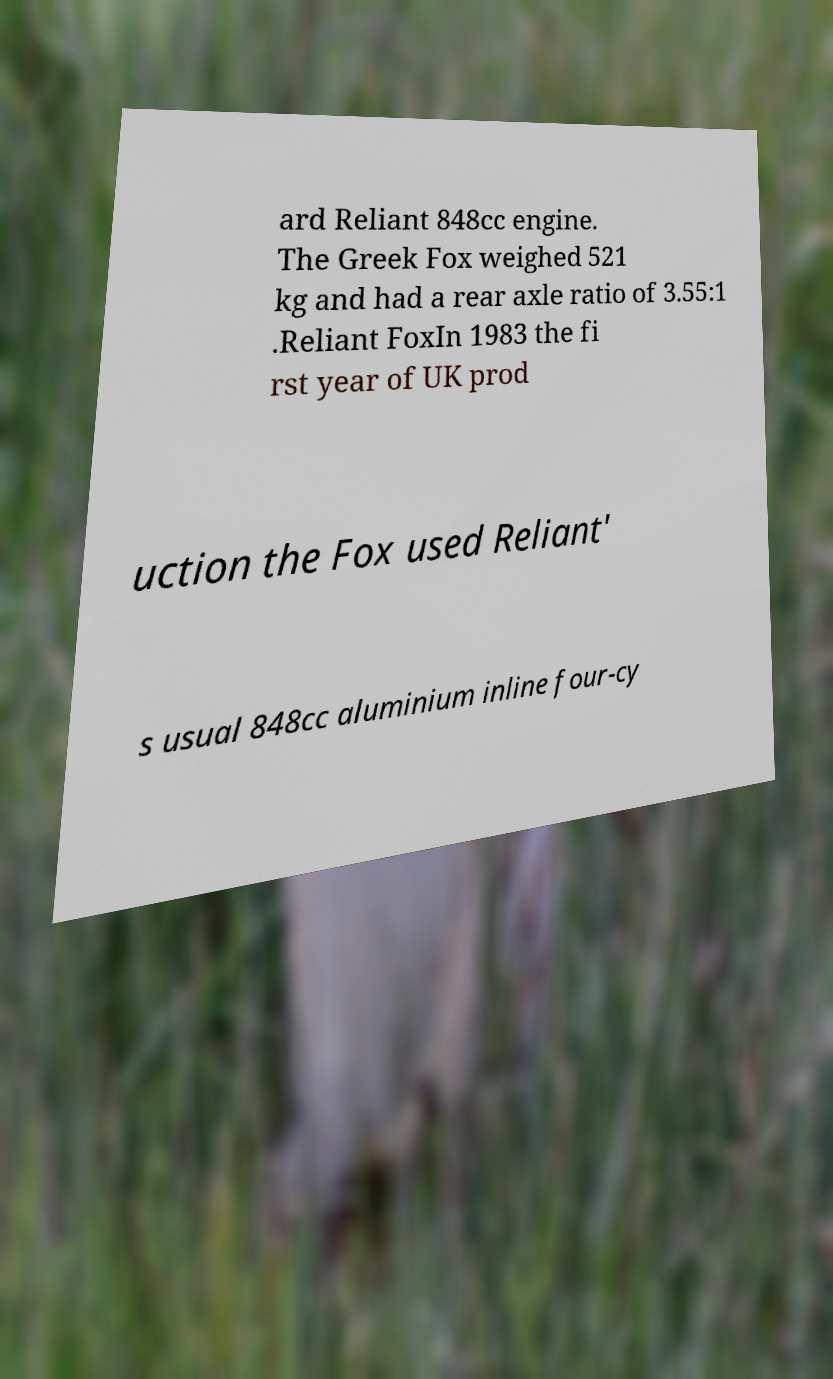Can you accurately transcribe the text from the provided image for me? ard Reliant 848cc engine. The Greek Fox weighed 521 kg and had a rear axle ratio of 3.55:1 .Reliant FoxIn 1983 the fi rst year of UK prod uction the Fox used Reliant' s usual 848cc aluminium inline four-cy 